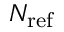Convert formula to latex. <formula><loc_0><loc_0><loc_500><loc_500>N _ { r e f }</formula> 